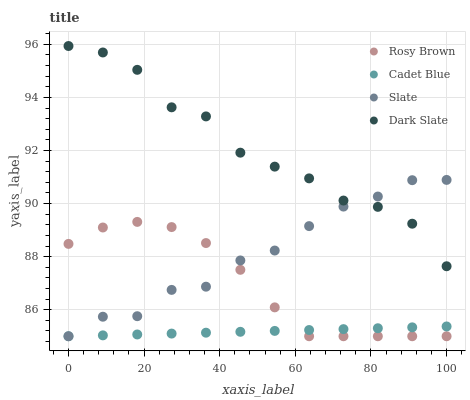Does Cadet Blue have the minimum area under the curve?
Answer yes or no. Yes. Does Dark Slate have the maximum area under the curve?
Answer yes or no. Yes. Does Slate have the minimum area under the curve?
Answer yes or no. No. Does Slate have the maximum area under the curve?
Answer yes or no. No. Is Cadet Blue the smoothest?
Answer yes or no. Yes. Is Dark Slate the roughest?
Answer yes or no. Yes. Is Slate the smoothest?
Answer yes or no. No. Is Slate the roughest?
Answer yes or no. No. Does Cadet Blue have the lowest value?
Answer yes or no. Yes. Does Dark Slate have the lowest value?
Answer yes or no. No. Does Dark Slate have the highest value?
Answer yes or no. Yes. Does Slate have the highest value?
Answer yes or no. No. Is Rosy Brown less than Dark Slate?
Answer yes or no. Yes. Is Dark Slate greater than Rosy Brown?
Answer yes or no. Yes. Does Cadet Blue intersect Rosy Brown?
Answer yes or no. Yes. Is Cadet Blue less than Rosy Brown?
Answer yes or no. No. Is Cadet Blue greater than Rosy Brown?
Answer yes or no. No. Does Rosy Brown intersect Dark Slate?
Answer yes or no. No. 